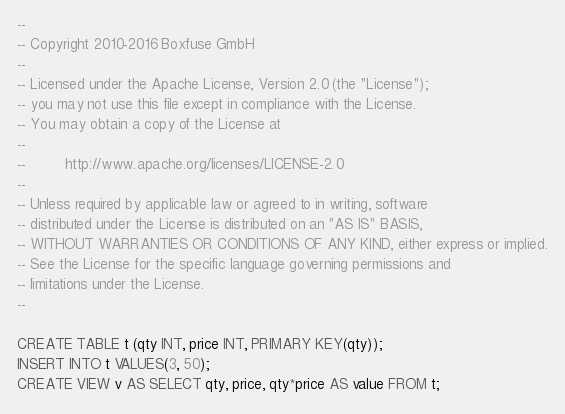Convert code to text. <code><loc_0><loc_0><loc_500><loc_500><_SQL_>--
-- Copyright 2010-2016 Boxfuse GmbH
--
-- Licensed under the Apache License, Version 2.0 (the "License");
-- you may not use this file except in compliance with the License.
-- You may obtain a copy of the License at
--
--         http://www.apache.org/licenses/LICENSE-2.0
--
-- Unless required by applicable law or agreed to in writing, software
-- distributed under the License is distributed on an "AS IS" BASIS,
-- WITHOUT WARRANTIES OR CONDITIONS OF ANY KIND, either express or implied.
-- See the License for the specific language governing permissions and
-- limitations under the License.
--

CREATE TABLE t (qty INT, price INT, PRIMARY KEY(qty));
INSERT INTO t VALUES(3, 50);
CREATE VIEW v AS SELECT qty, price, qty*price AS value FROM t;
</code> 